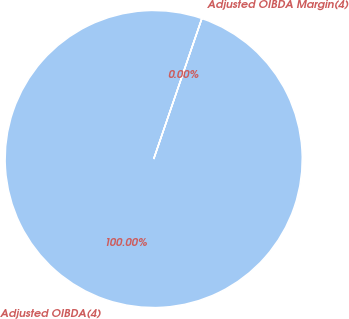Convert chart to OTSL. <chart><loc_0><loc_0><loc_500><loc_500><pie_chart><fcel>Adjusted OIBDA(4)<fcel>Adjusted OIBDA Margin(4)<nl><fcel>100.0%<fcel>0.0%<nl></chart> 